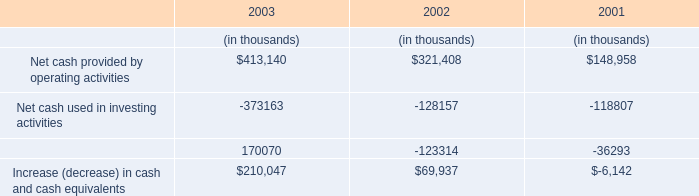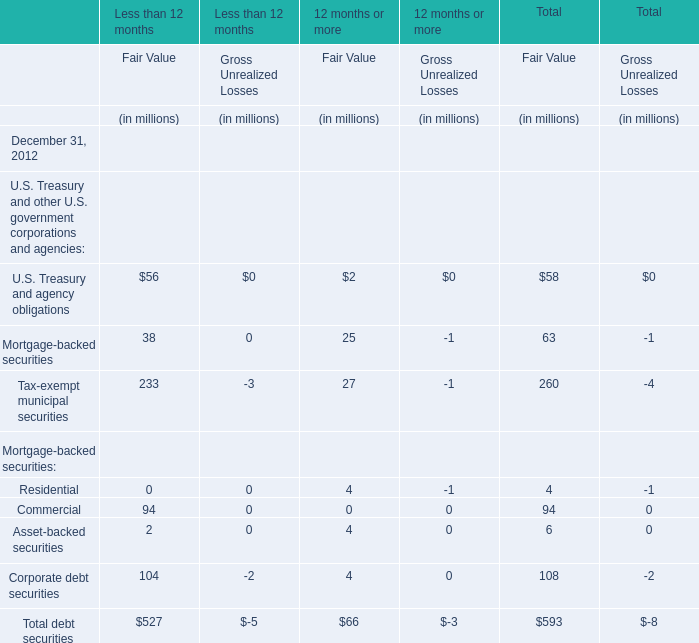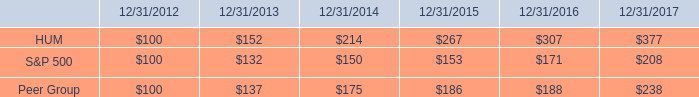What is the percentage of all Fair Value that are positive to the total amount, in in 2012 for 12 months or more? 
Computations: ((((((2 + 25) + 27) + 4) + 4) + 4) / 66)
Answer: 1.0. 